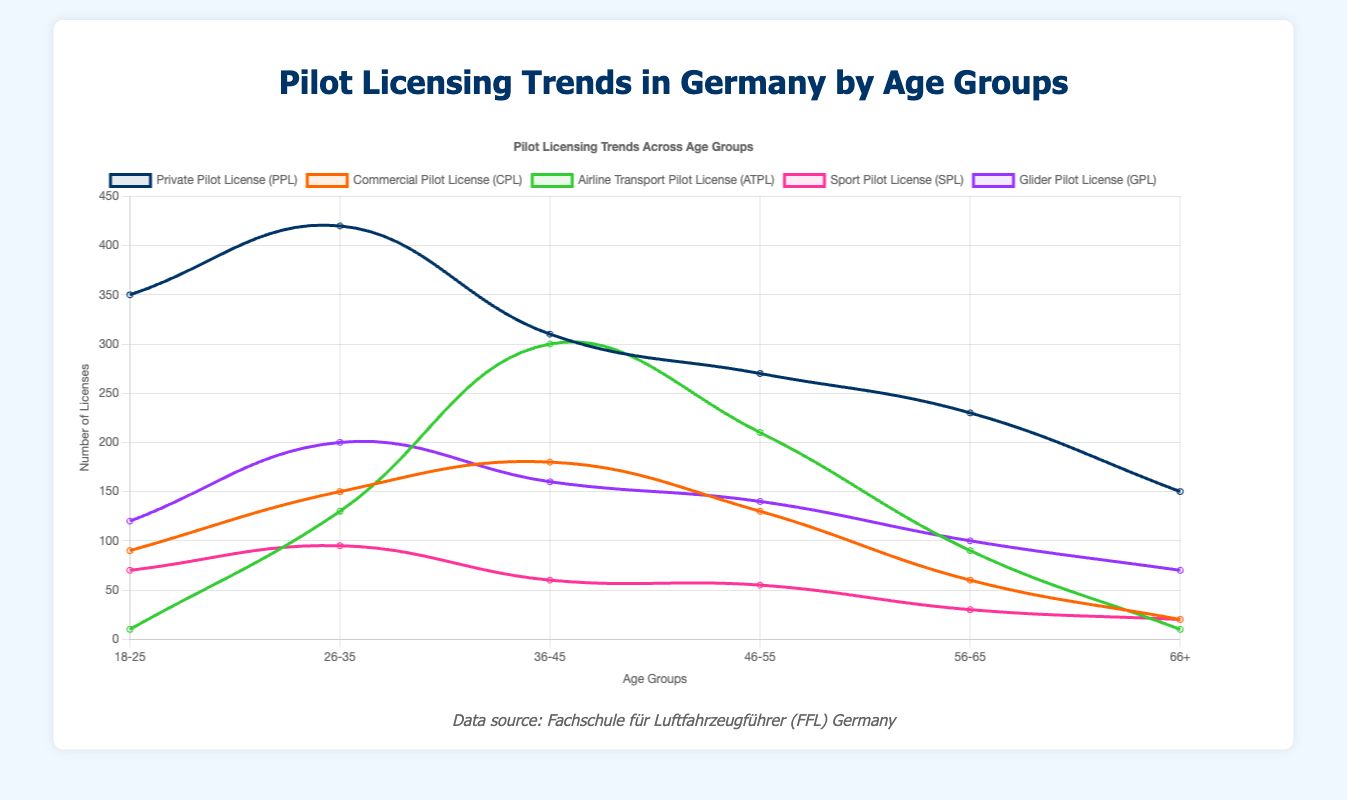Which age group has the highest number of Private Pilot Licenses (PPL)? The figure shows the data for PPL across different age groups. By comparing the heights of the lines corresponding to PPL for each age group, the 26-35 age group appears the highest.
Answer: 26-35 Which two age groups combined have the highest total number of Airline Transport Pilot Licenses (ATPL)? Adding the values for ATPL in each age group, 36-45 has 300 and 46-55 has 210, which add up to 510, the highest.
Answer: 36-45 and 46-55 In which age group is the number of Private Pilot Licenses (PPL) the lowest? By checking the lowest point of the line corresponding to PPL, the 66+ age group has the smallest number.
Answer: 66+ Compare the number of Glider Pilot Licenses (GPL) for age groups 18-25 and 56-65. Which age group has more, and by how much? The 18-25 age group has 120 GPL, and the 56-65 age group has 100 GPL. Subtracting these, 18-25 has 20 more.
Answer: 18-25 by 20 How does the trend of Commercial Pilot Licenses (CPL) change across the age groups? The trend starts at 90 for 18-25, rises to a peak of 180 at 36-45, and then consistently decreases to 20 at 66+. This shows an initial increase and subsequent continuous decrease.
Answer: Rises then falls What is the total number of Sport Pilot Licenses (SPL) across all age groups? Summing up the SPL values for all age groups: 70+95+60+55+30+20 = 330.
Answer: 330 For the age group 26-35, which license type has the second highest count? From the data points at 26-35, the highest is PPL with 420, and the second highest is GPL with 200.
Answer: GPL Which license type shows the most significant drop from the 36-45 age group to the 46-55 age group? Comparing the decrement for each license type, the ATPL count drops from 300 to 210, a difference of 90, which is the largest decline.
Answer: ATPL What is the combined total of Private Pilot Licenses (PPL) and Glider Pilot Licenses (GPL) for the 46-55 age group? Adding the value of PPL (270) and GPL (140) in the 46-55 age group: 270 + 140 = 410.
Answer: 410 